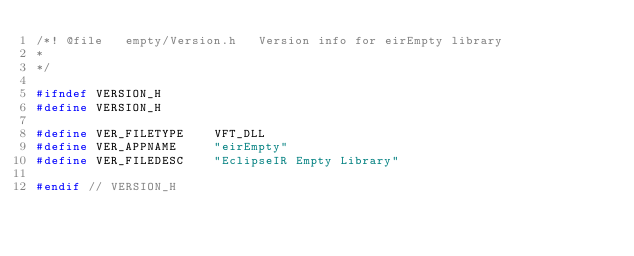Convert code to text. <code><loc_0><loc_0><loc_500><loc_500><_C_>/*! @file   empty/Version.h   Version info for eirEmpty library
*
*/

#ifndef VERSION_H
#define VERSION_H

#define VER_FILETYPE    VFT_DLL
#define VER_APPNAME     "eirEmpty"
#define VER_FILEDESC    "EclipseIR Empty Library"

#endif // VERSION_H
</code> 